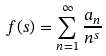Convert formula to latex. <formula><loc_0><loc_0><loc_500><loc_500>f ( s ) = \sum _ { n = 1 } ^ { \infty } \frac { a _ { n } } { n ^ { s } }</formula> 